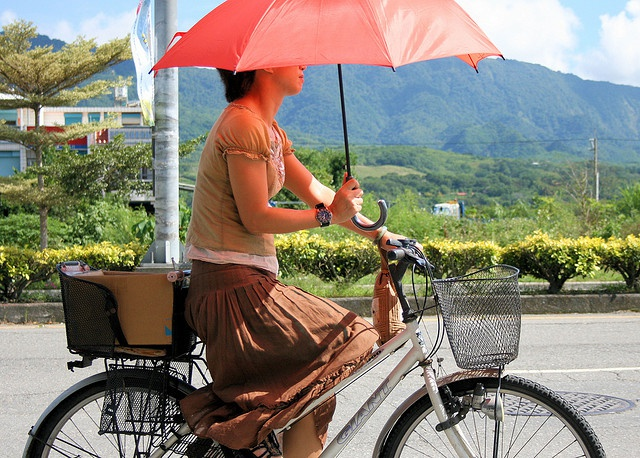Describe the objects in this image and their specific colors. I can see people in lightblue, black, maroon, and brown tones, bicycle in lightblue, black, lightgray, gray, and darkgray tones, umbrella in lightblue, salmon, and pink tones, and handbag in lightblue, maroon, and brown tones in this image. 